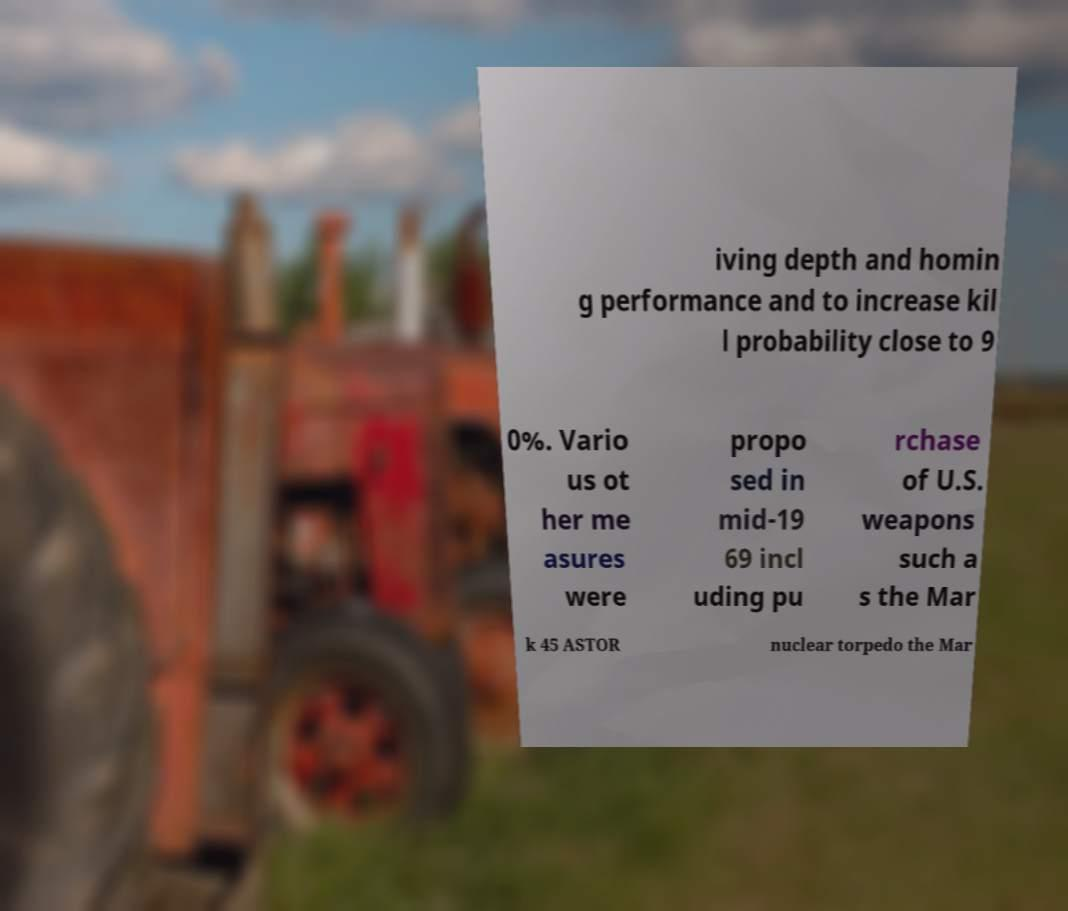Can you accurately transcribe the text from the provided image for me? iving depth and homin g performance and to increase kil l probability close to 9 0%. Vario us ot her me asures were propo sed in mid-19 69 incl uding pu rchase of U.S. weapons such a s the Mar k 45 ASTOR nuclear torpedo the Mar 